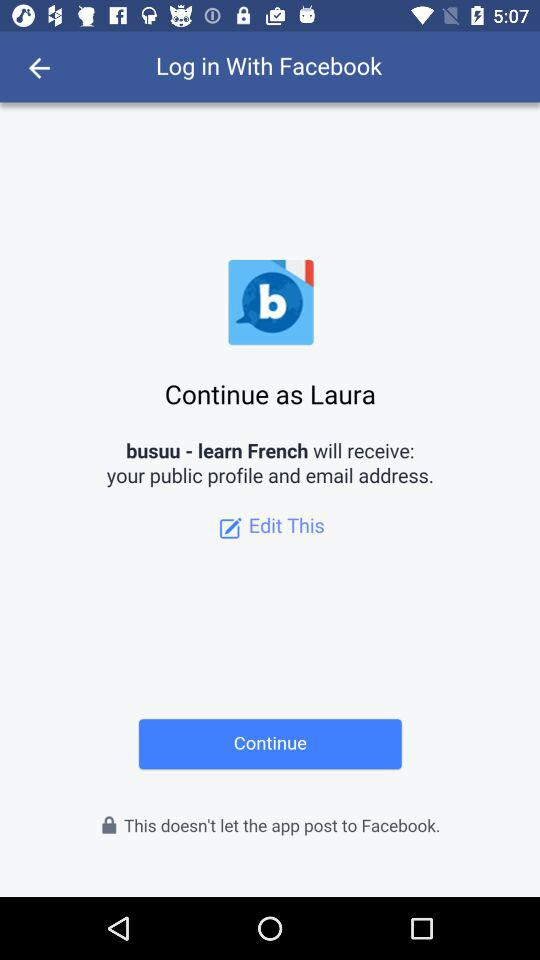Who will receive the public figure and email address? The public figure and email address are received by "busuu - learn French". 